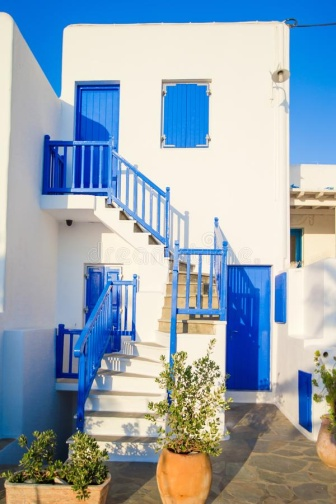Can you explain the purpose of the blue color used on the windows, doors, and stairs? The use of blue on the windows, doors, and stairs in the image not only adds a visually striking element to the building but also holds cultural and practical significance. In many Mediterranean cultures, blue is believed to ward off the 'evil eye' and is a symbol of protection and peace. Practically, the blue also contrasts beautifully against the white walls, mirroring the blue of the sky and sea commonly found in Mediterranean landscapes, thus reinforcing the local aesthetic and blending the structure with its environment. 